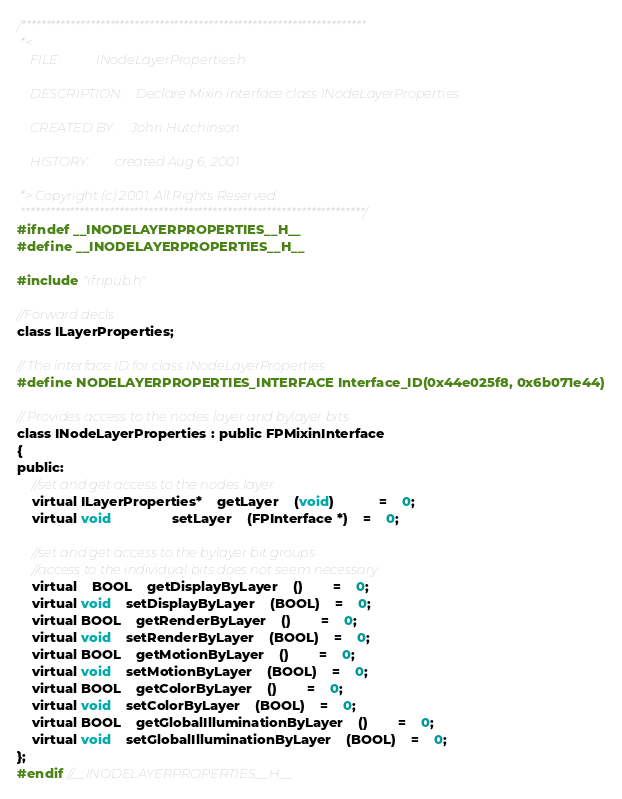<code> <loc_0><loc_0><loc_500><loc_500><_C_>/**********************************************************************
 *<
	FILE:			INodeLayerProperties.h

	DESCRIPTION:	Declare Mixin interface class INodeLayerProperties
											 
	CREATED BY:		John Hutchinson

	HISTORY:		created Aug 6, 2001

 *>	Copyright (c) 2001, All Rights Reserved.
 **********************************************************************/
#ifndef __INODELAYERPROPERTIES__H__
#define __INODELAYERPROPERTIES__H__

#include "ifnpub.h"

//Forward decls
class ILayerProperties;

// The interface ID for class INodeLayerProperties
#define NODELAYERPROPERTIES_INTERFACE Interface_ID(0x44e025f8, 0x6b071e44)

// Provides access to the nodes layer and bylayer bits
class INodeLayerProperties : public FPMixinInterface
{
public:
	//set and get access to the nodes layer
	virtual ILayerProperties*	getLayer	(void)			=	0;
	virtual void				setLayer	(FPInterface *)	=	0;

	//set and get access to the bylayer bit groups
	//access to the individual bits does not seem necessary 
	virtual	BOOL	getDisplayByLayer	()		=	0;
	virtual void	setDisplayByLayer	(BOOL)	=	0;
	virtual BOOL	getRenderByLayer	()		=	0;
	virtual void	setRenderByLayer	(BOOL)	=	0;
	virtual BOOL	getMotionByLayer	()		=	0;
	virtual void	setMotionByLayer	(BOOL)	=	0;
	virtual BOOL	getColorByLayer	()		=	0;
	virtual void	setColorByLayer	(BOOL)	=	0;
	virtual BOOL	getGlobalIlluminationByLayer	()		=	0;
	virtual void	setGlobalIlluminationByLayer	(BOOL)	=	0;
};
#endif //__INODELAYERPROPERTIES__H__</code> 